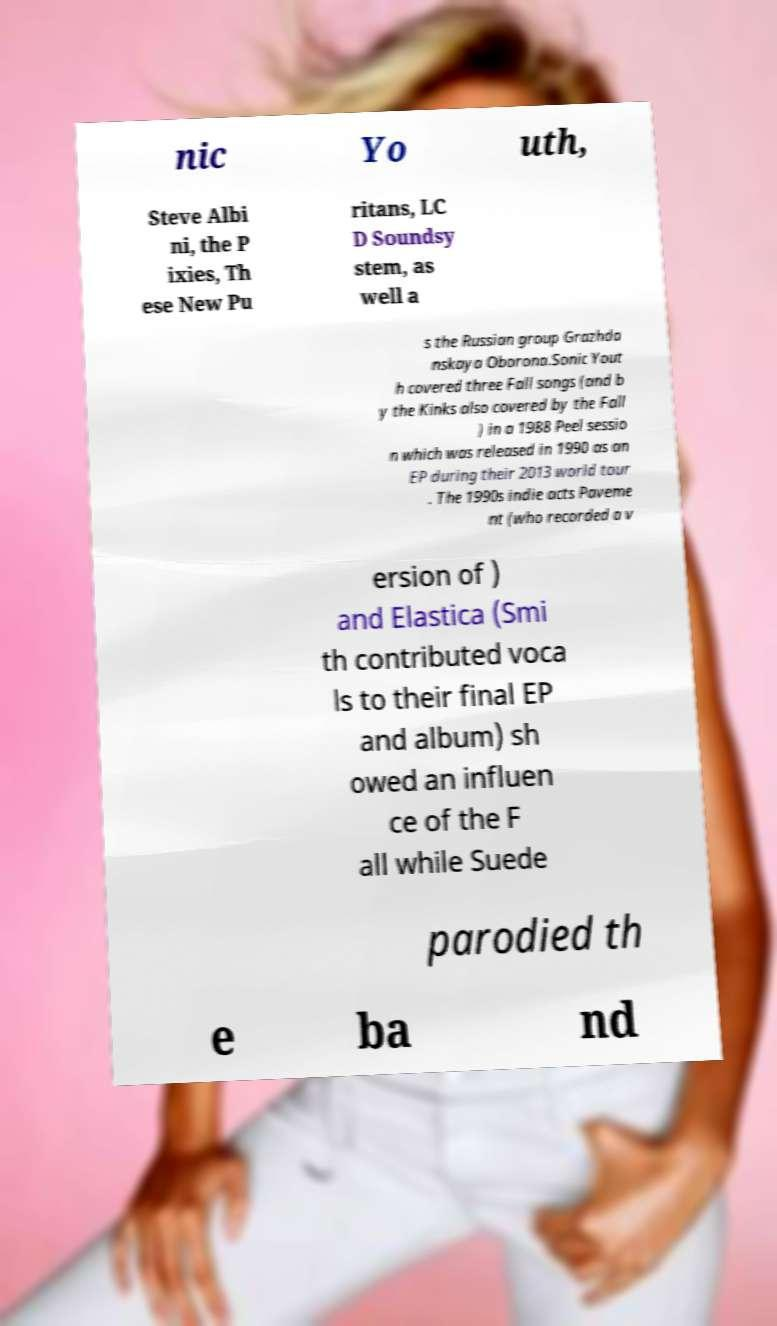What messages or text are displayed in this image? I need them in a readable, typed format. nic Yo uth, Steve Albi ni, the P ixies, Th ese New Pu ritans, LC D Soundsy stem, as well a s the Russian group Grazhda nskaya Oborona.Sonic Yout h covered three Fall songs (and b y the Kinks also covered by the Fall ) in a 1988 Peel sessio n which was released in 1990 as an EP during their 2013 world tour . The 1990s indie acts Paveme nt (who recorded a v ersion of ) and Elastica (Smi th contributed voca ls to their final EP and album) sh owed an influen ce of the F all while Suede parodied th e ba nd 